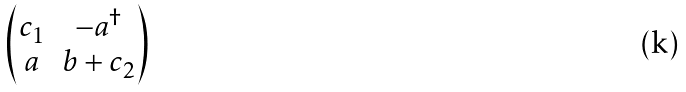Convert formula to latex. <formula><loc_0><loc_0><loc_500><loc_500>\begin{pmatrix} c _ { 1 } & - a ^ { \dagger } \\ a & b + c _ { 2 } \end{pmatrix}</formula> 